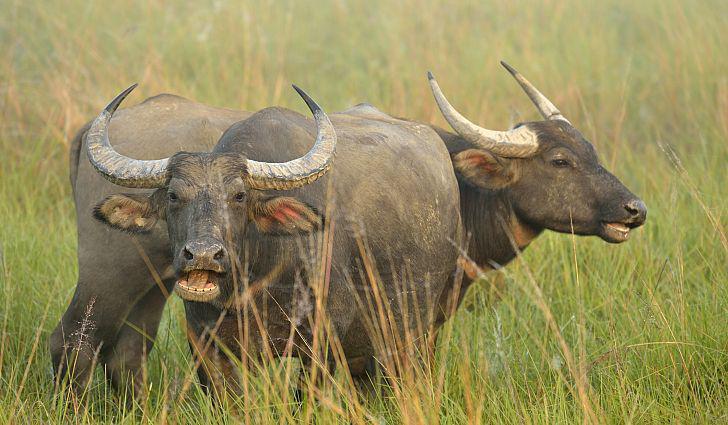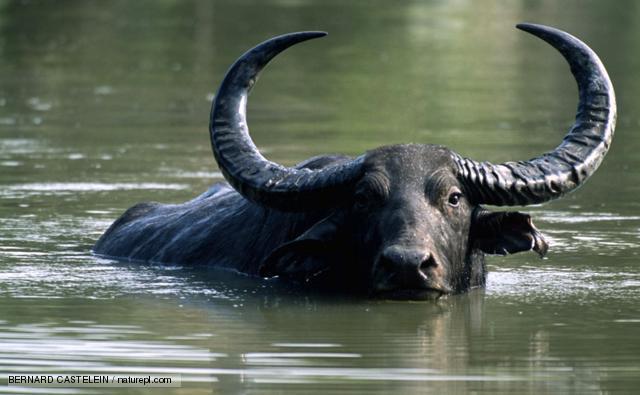The first image is the image on the left, the second image is the image on the right. For the images shown, is this caption "the image on the right contains a water buffalo whose body is submerged in water." true? Answer yes or no. Yes. The first image is the image on the left, the second image is the image on the right. Analyze the images presented: Is the assertion "In one image, a water buffalo is submerged in water with its head and upper body showing." valid? Answer yes or no. Yes. The first image is the image on the left, the second image is the image on the right. For the images shown, is this caption "A single horned animal is in the water." true? Answer yes or no. Yes. The first image is the image on the left, the second image is the image on the right. Examine the images to the left and right. Is the description "An image shows exactly one water buffalo at least waist deep in water." accurate? Answer yes or no. Yes. 